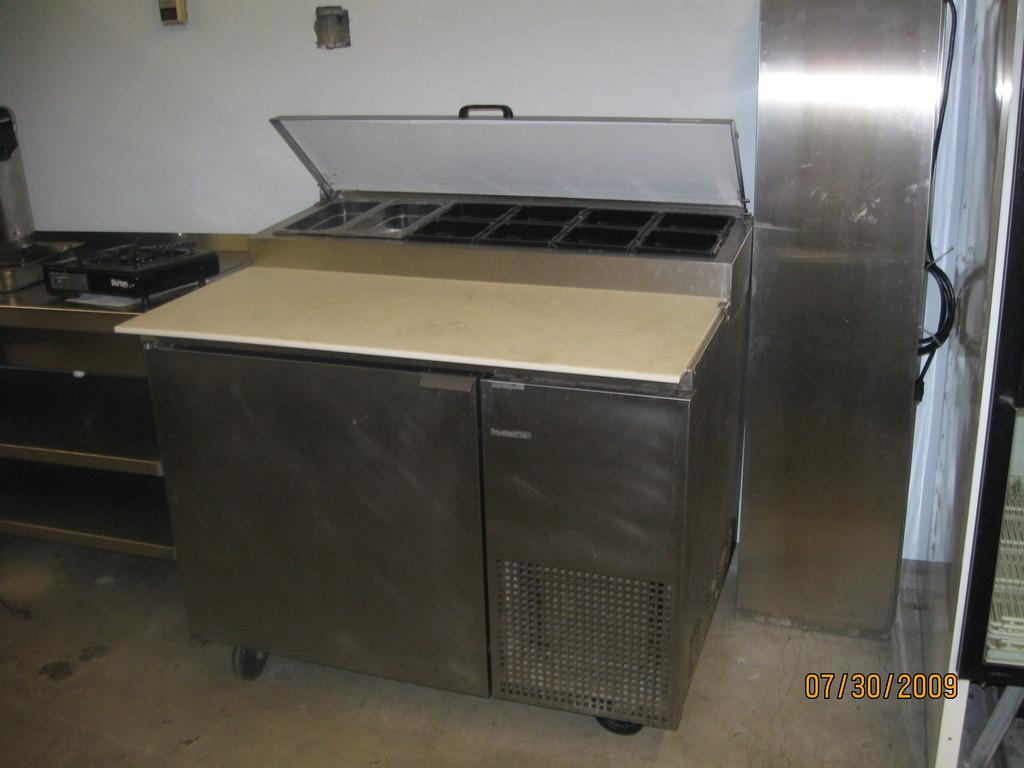<image>
Present a compact description of the photo's key features. the inside of a kitchen, the photo taken on July 30th, 2009 